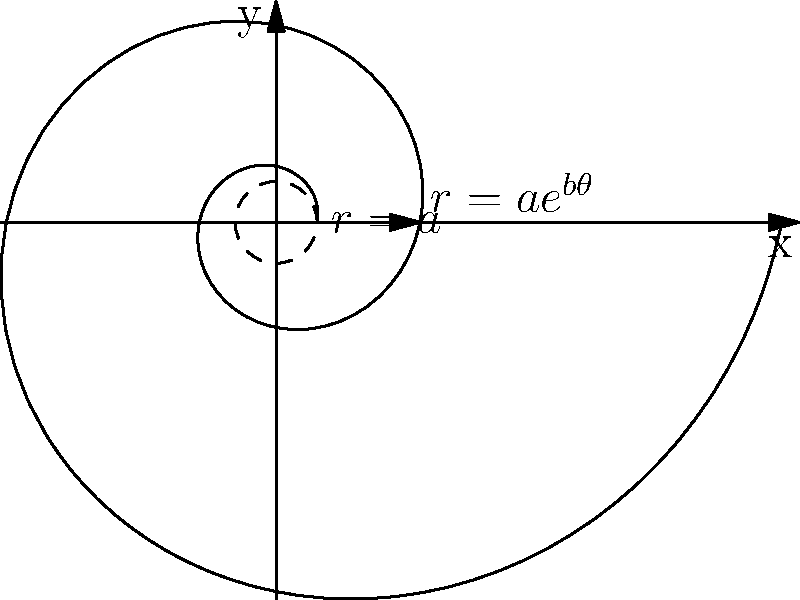In Haitian literature, the conch shell often symbolizes resilience and cultural heritage. Consider a spiral pattern inspired by a conch shell, represented by the polar equation $r = ae^{b\theta}$, where $a$ and $b$ are positive constants. After one complete revolution ($\theta = 2\pi$), what is the ratio of the spiral's radius to its initial radius? To solve this problem, let's follow these steps:

1) The initial radius (at $\theta = 0$) is given by:
   $r_0 = ae^{b \cdot 0} = a$

2) After one complete revolution ($\theta = 2\pi$), the radius is:
   $r_{2\pi} = ae^{b \cdot 2\pi}$

3) The ratio of these radii is:
   $$\frac{r_{2\pi}}{r_0} = \frac{ae^{b \cdot 2\pi}}{a}$$

4) The $a$ cancels out:
   $$\frac{r_{2\pi}}{r_0} = e^{b \cdot 2\pi}$$

5) This can be written as:
   $$\frac{r_{2\pi}}{r_0} = (e^{2\pi})^b$$

Thus, after one complete revolution, the spiral's radius is $e^{2\pi b}$ times its initial radius.

This exponential growth reflects the symbolic resilience in Haitian literature, where the conch shell often represents endurance and cultural continuity despite adversity.
Answer: $e^{2\pi b}$ 